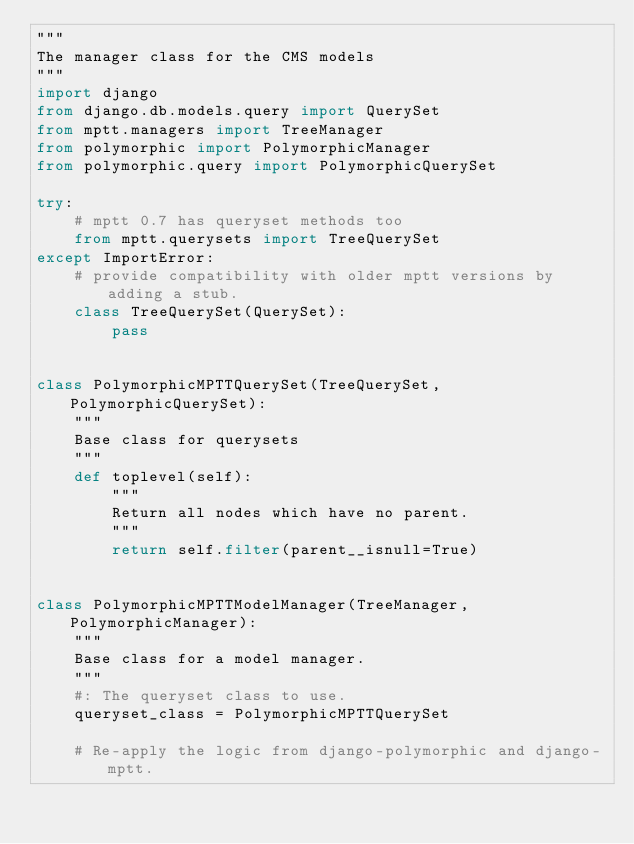Convert code to text. <code><loc_0><loc_0><loc_500><loc_500><_Python_>"""
The manager class for the CMS models
"""
import django
from django.db.models.query import QuerySet
from mptt.managers import TreeManager
from polymorphic import PolymorphicManager
from polymorphic.query import PolymorphicQuerySet

try:
    # mptt 0.7 has queryset methods too
    from mptt.querysets import TreeQuerySet
except ImportError:
    # provide compatibility with older mptt versions by adding a stub.
    class TreeQuerySet(QuerySet):
        pass


class PolymorphicMPTTQuerySet(TreeQuerySet, PolymorphicQuerySet):
    """
    Base class for querysets
    """
    def toplevel(self):
        """
        Return all nodes which have no parent.
        """
        return self.filter(parent__isnull=True)


class PolymorphicMPTTModelManager(TreeManager, PolymorphicManager):
    """
    Base class for a model manager.
    """
    #: The queryset class to use.
    queryset_class = PolymorphicMPTTQuerySet

    # Re-apply the logic from django-polymorphic and django-mptt.</code> 